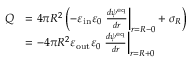Convert formula to latex. <formula><loc_0><loc_0><loc_500><loc_500>\begin{array} { r l } { Q } & { = 4 \pi R ^ { 2 } \left ( - \varepsilon _ { i n } \varepsilon _ { 0 } \frac { d \psi ^ { e q } } { d r } \right | _ { r = R - 0 } + \sigma _ { R } \right ) } \\ & { = - 4 \pi R ^ { 2 } \varepsilon _ { o u t } \varepsilon _ { 0 } \frac { d \psi ^ { e q } } { d r } \right | _ { r = R + 0 } } \end{array}</formula> 